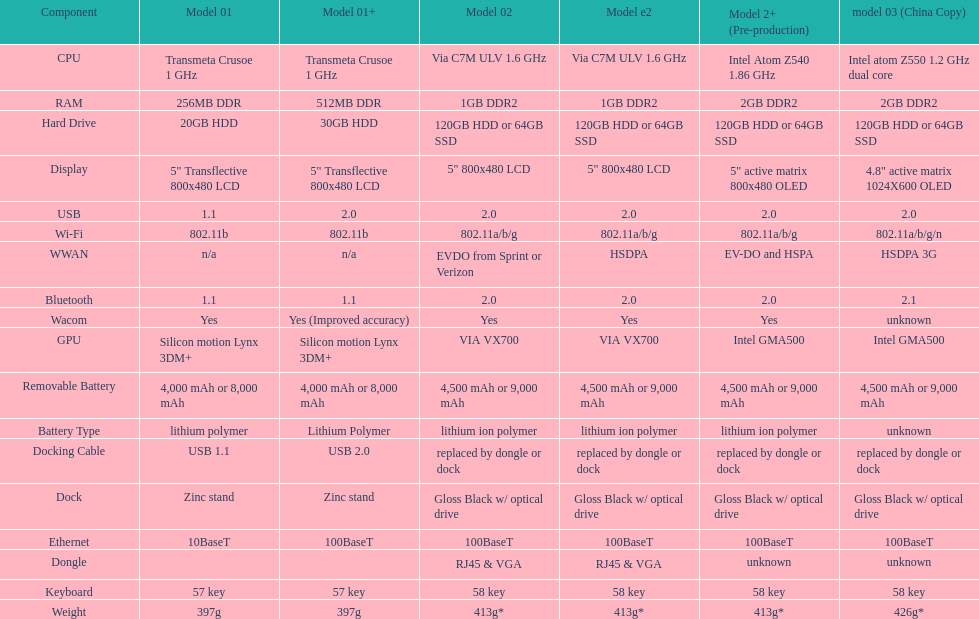I'm looking to parse the entire table for insights. Could you assist me with that? {'header': ['Component', 'Model 01', 'Model 01+', 'Model 02', 'Model e2', 'Model 2+ (Pre-production)', 'model 03 (China Copy)'], 'rows': [['CPU', 'Transmeta Crusoe 1\xa0GHz', 'Transmeta Crusoe 1\xa0GHz', 'Via C7M ULV 1.6\xa0GHz', 'Via C7M ULV 1.6\xa0GHz', 'Intel Atom Z540 1.86\xa0GHz', 'Intel atom Z550 1.2\xa0GHz dual core'], ['RAM', '256MB DDR', '512MB DDR', '1GB DDR2', '1GB DDR2', '2GB DDR2', '2GB DDR2'], ['Hard Drive', '20GB HDD', '30GB HDD', '120GB HDD or 64GB SSD', '120GB HDD or 64GB SSD', '120GB HDD or 64GB SSD', '120GB HDD or 64GB SSD'], ['Display', '5" Transflective 800x480 LCD', '5" Transflective 800x480 LCD', '5" 800x480 LCD', '5" 800x480 LCD', '5" active matrix 800x480 OLED', '4.8" active matrix 1024X600 OLED'], ['USB', '1.1', '2.0', '2.0', '2.0', '2.0', '2.0'], ['Wi-Fi', '802.11b', '802.11b', '802.11a/b/g', '802.11a/b/g', '802.11a/b/g', '802.11a/b/g/n'], ['WWAN', 'n/a', 'n/a', 'EVDO from Sprint or Verizon', 'HSDPA', 'EV-DO and HSPA', 'HSDPA 3G'], ['Bluetooth', '1.1', '1.1', '2.0', '2.0', '2.0', '2.1'], ['Wacom', 'Yes', 'Yes (Improved accuracy)', 'Yes', 'Yes', 'Yes', 'unknown'], ['GPU', 'Silicon motion Lynx 3DM+', 'Silicon motion Lynx 3DM+', 'VIA VX700', 'VIA VX700', 'Intel GMA500', 'Intel GMA500'], ['Removable Battery', '4,000 mAh or 8,000 mAh', '4,000 mAh or 8,000 mAh', '4,500 mAh or 9,000 mAh', '4,500 mAh or 9,000 mAh', '4,500 mAh or 9,000 mAh', '4,500 mAh or 9,000 mAh'], ['Battery Type', 'lithium polymer', 'Lithium Polymer', 'lithium ion polymer', 'lithium ion polymer', 'lithium ion polymer', 'unknown'], ['Docking Cable', 'USB 1.1', 'USB 2.0', 'replaced by dongle or dock', 'replaced by dongle or dock', 'replaced by dongle or dock', 'replaced by dongle or dock'], ['Dock', 'Zinc stand', 'Zinc stand', 'Gloss Black w/ optical drive', 'Gloss Black w/ optical drive', 'Gloss Black w/ optical drive', 'Gloss Black w/ optical drive'], ['Ethernet', '10BaseT', '100BaseT', '100BaseT', '100BaseT', '100BaseT', '100BaseT'], ['Dongle', '', '', 'RJ45 & VGA', 'RJ45 & VGA', 'unknown', 'unknown'], ['Keyboard', '57 key', '57 key', '58 key', '58 key', '58 key', '58 key'], ['Weight', '397g', '397g', '413g*', '413g*', '413g*', '426g*']]} What component comes after bluetooth? Wacom. 